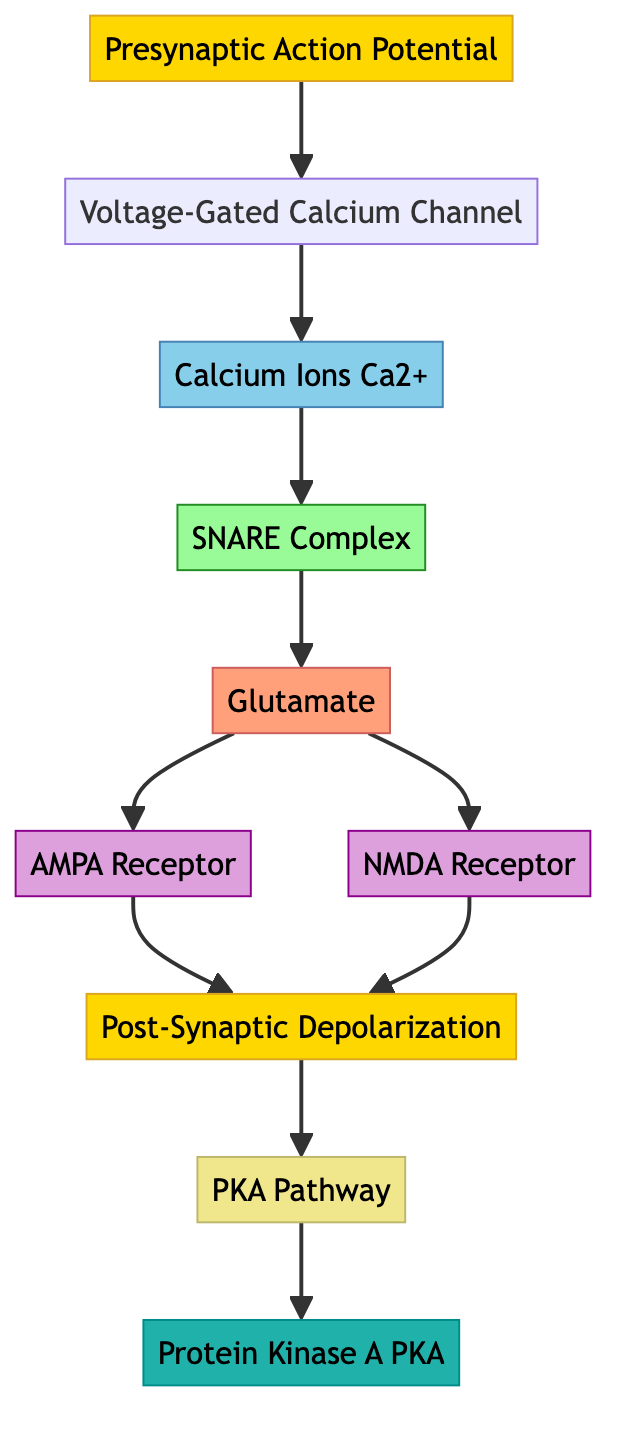What initiates the signal transduction pathway in neuronal cells? The signal transduction pathway begins with the presynaptic action potential, which is an electrical impulse traveling along the axon to the synaptic terminal.
Answer: Presynaptic Action Potential Which channel opens in response to the presynaptic action potential? The voltage-gated calcium channel opens when the presynaptic action potential reaches the synaptic terminal.
Answer: Voltage-Gated Calcium Channel How many receptors are activated by glutamate in the post-synaptic neuron? Glutamate activates two receptors: the AMPA receptor and the NMDA receptor.
Answer: Two What is the role of calcium ions in neurotransmitter release? Calcium ions enter the presynaptic terminal and trigger the fusion of neurotransmitter vesicles with the presynaptic membrane, leading to release.
Answer: Trigger fusion What results from the activation of the AMPA and NMDA receptors? The activation of the AMPA and NMDA receptors leads to post-synaptic depolarization, changing the membrane potential and potentially generating an action potential in the post-synaptic neuron.
Answer: Post-Synaptic Depolarization What is a secondary pathway influenced by post-synaptic depolarization? The PKA pathway is the secondary pathway influenced by post-synaptic depolarization, which involves cAMP and Protein Kinase A.
Answer: PKA Pathway Which enzyme is involved in the regulation of synaptic plasticity? Protein Kinase A (PKA) is the enzyme involved in the regulation of synaptic plasticity as it's activated by cAMP.
Answer: Protein Kinase A What is the primary neurotransmitter released in this pathway? The primary neurotransmitter released in the synaptic cleft is glutamate, which is excitatory.
Answer: Glutamate Which ion enters the post-synaptic neuron via NMDA receptors? Calcium ions (Ca2+) and sodium ions (Na+) enter the post-synaptic neuron through NMDA receptors.
Answer: Calcium and Sodium ions 